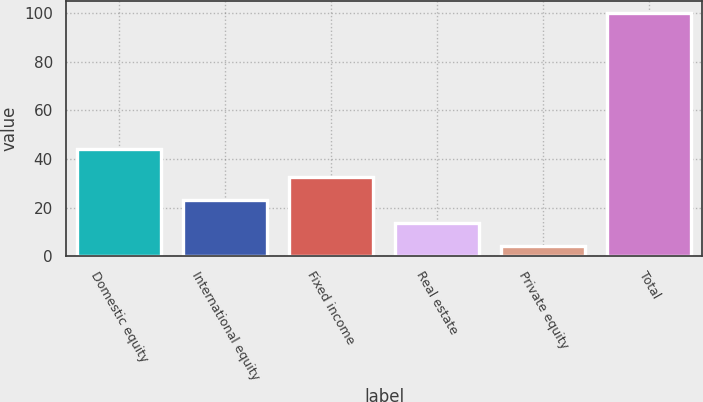<chart> <loc_0><loc_0><loc_500><loc_500><bar_chart><fcel>Domestic equity<fcel>International equity<fcel>Fixed income<fcel>Real estate<fcel>Private equity<fcel>Total<nl><fcel>44<fcel>23.2<fcel>32.8<fcel>13.6<fcel>4<fcel>100<nl></chart> 